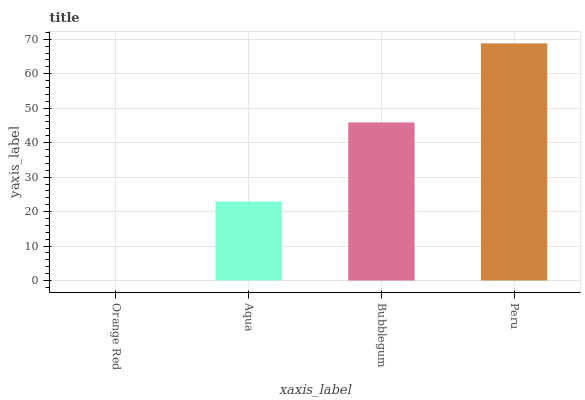Is Orange Red the minimum?
Answer yes or no. Yes. Is Peru the maximum?
Answer yes or no. Yes. Is Aqua the minimum?
Answer yes or no. No. Is Aqua the maximum?
Answer yes or no. No. Is Aqua greater than Orange Red?
Answer yes or no. Yes. Is Orange Red less than Aqua?
Answer yes or no. Yes. Is Orange Red greater than Aqua?
Answer yes or no. No. Is Aqua less than Orange Red?
Answer yes or no. No. Is Bubblegum the high median?
Answer yes or no. Yes. Is Aqua the low median?
Answer yes or no. Yes. Is Aqua the high median?
Answer yes or no. No. Is Orange Red the low median?
Answer yes or no. No. 